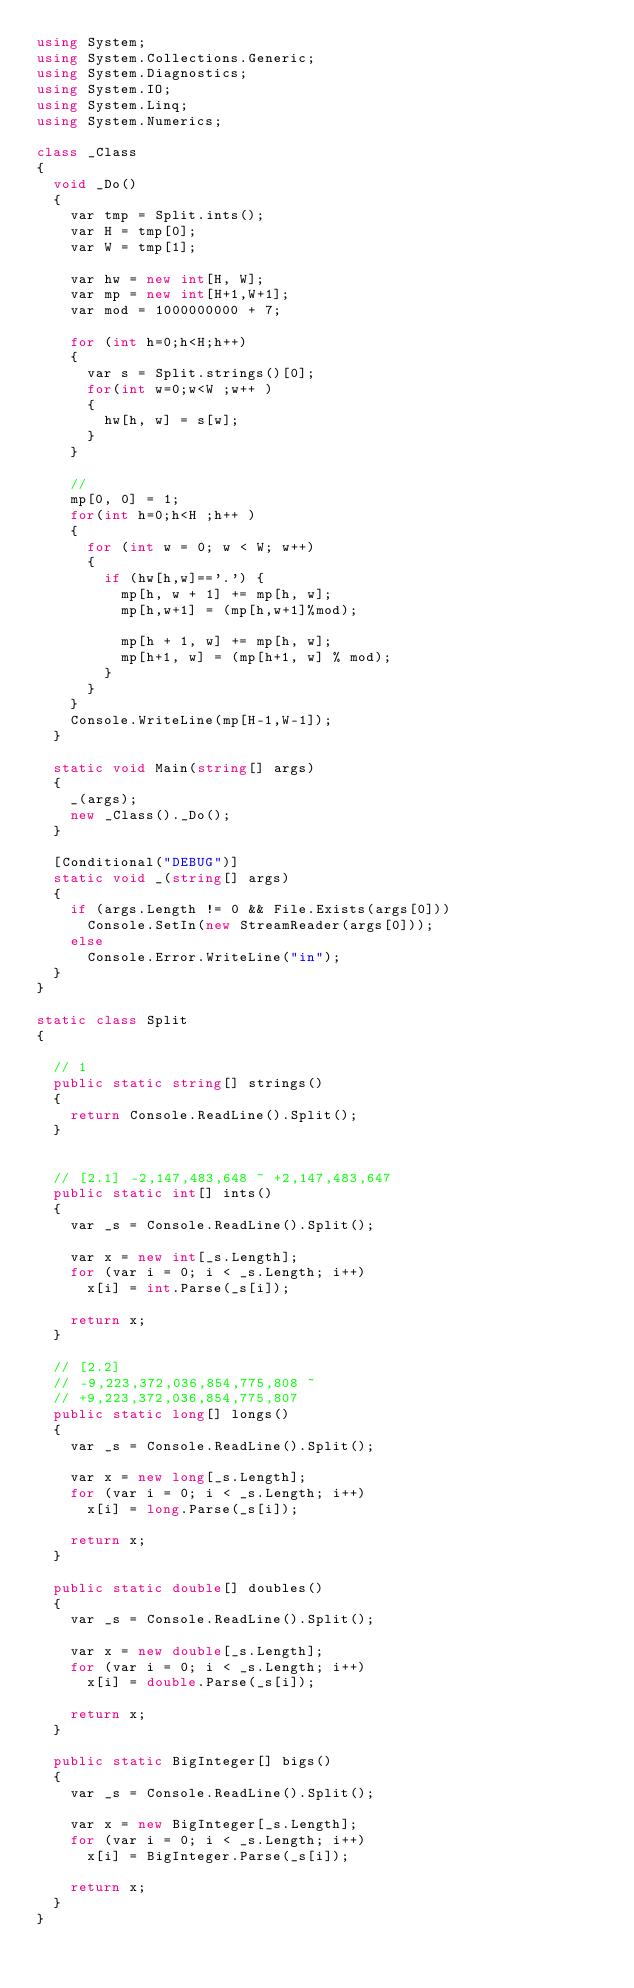<code> <loc_0><loc_0><loc_500><loc_500><_C#_>using System;
using System.Collections.Generic;
using System.Diagnostics;
using System.IO;
using System.Linq;
using System.Numerics;

class _Class
{
  void _Do()
  {
    var tmp = Split.ints();
    var H = tmp[0];
    var W = tmp[1];

    var hw = new int[H, W];
    var mp = new int[H+1,W+1];
    var mod = 1000000000 + 7;

    for (int h=0;h<H;h++)
    {
      var s = Split.strings()[0];
      for(int w=0;w<W ;w++ )
      {
        hw[h, w] = s[w];
      }  
    }

    //
    mp[0, 0] = 1;
    for(int h=0;h<H ;h++ )
    {
      for (int w = 0; w < W; w++)
      {
        if (hw[h,w]=='.') {
          mp[h, w + 1] += mp[h, w];
          mp[h,w+1] = (mp[h,w+1]%mod);

          mp[h + 1, w] += mp[h, w];
          mp[h+1, w] = (mp[h+1, w] % mod);
        }
      }
    }
    Console.WriteLine(mp[H-1,W-1]);
  }

  static void Main(string[] args)
  {
    _(args);
    new _Class()._Do();
  }

  [Conditional("DEBUG")]
  static void _(string[] args)
  {
    if (args.Length != 0 && File.Exists(args[0]))
      Console.SetIn(new StreamReader(args[0]));
    else
      Console.Error.WriteLine("in");
  }
}

static class Split
{ 

  // 1
  public static string[] strings()
  {
    return Console.ReadLine().Split();
  }


  // [2.1] -2,147,483,648 ~ +2,147,483,647
  public static int[] ints()
  {
    var _s = Console.ReadLine().Split();

    var x = new int[_s.Length];
    for (var i = 0; i < _s.Length; i++)
      x[i] = int.Parse(_s[i]);

    return x;
  }

  // [2.2] 
  // -9,223,372,036,854,775,808 ~ 
  // +9,223,372,036,854,775,807
  public static long[] longs()
  {
    var _s = Console.ReadLine().Split();

    var x = new long[_s.Length];
    for (var i = 0; i < _s.Length; i++)
      x[i] = long.Parse(_s[i]);

    return x;
  }

  public static double[] doubles()
  {
    var _s = Console.ReadLine().Split();

    var x = new double[_s.Length];
    for (var i = 0; i < _s.Length; i++)
      x[i] = double.Parse(_s[i]);

    return x;
  }

  public static BigInteger[] bigs()
  {
    var _s = Console.ReadLine().Split();

    var x = new BigInteger[_s.Length];
    for (var i = 0; i < _s.Length; i++)
      x[i] = BigInteger.Parse(_s[i]);

    return x;
  }
}



</code> 